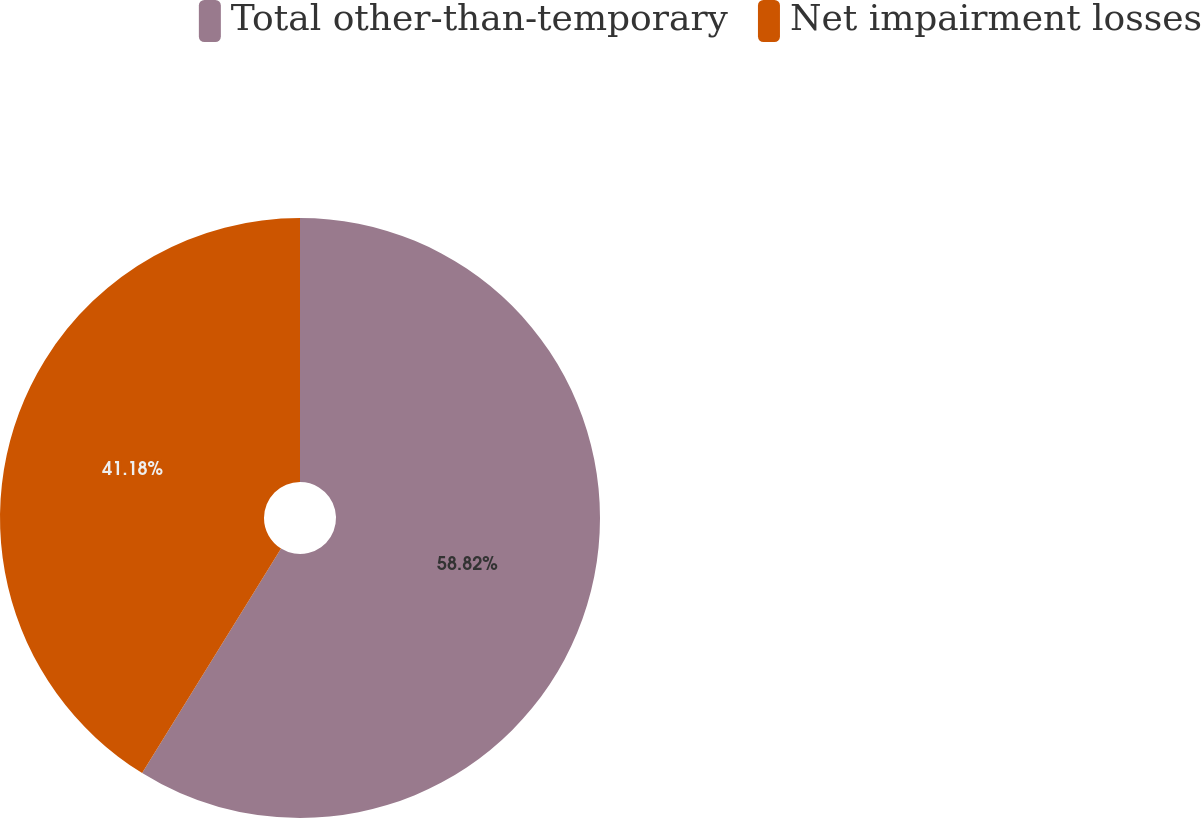Convert chart. <chart><loc_0><loc_0><loc_500><loc_500><pie_chart><fcel>Total other-than-temporary<fcel>Net impairment losses<nl><fcel>58.82%<fcel>41.18%<nl></chart> 